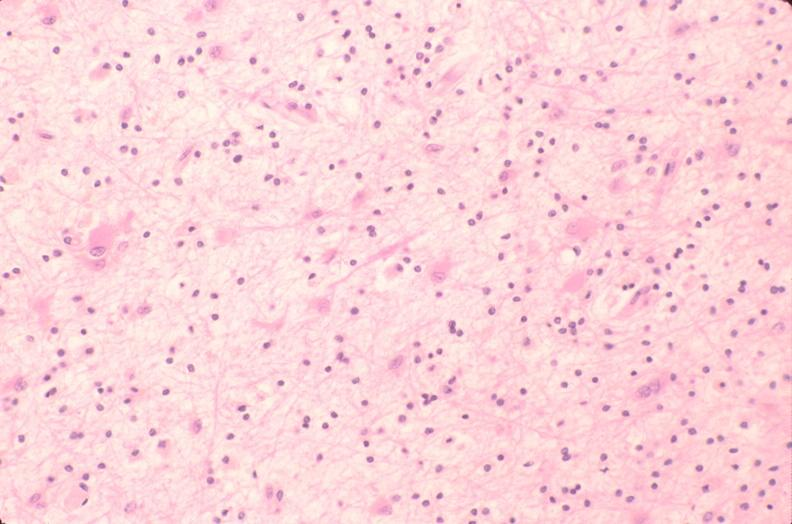s nervous present?
Answer the question using a single word or phrase. Yes 